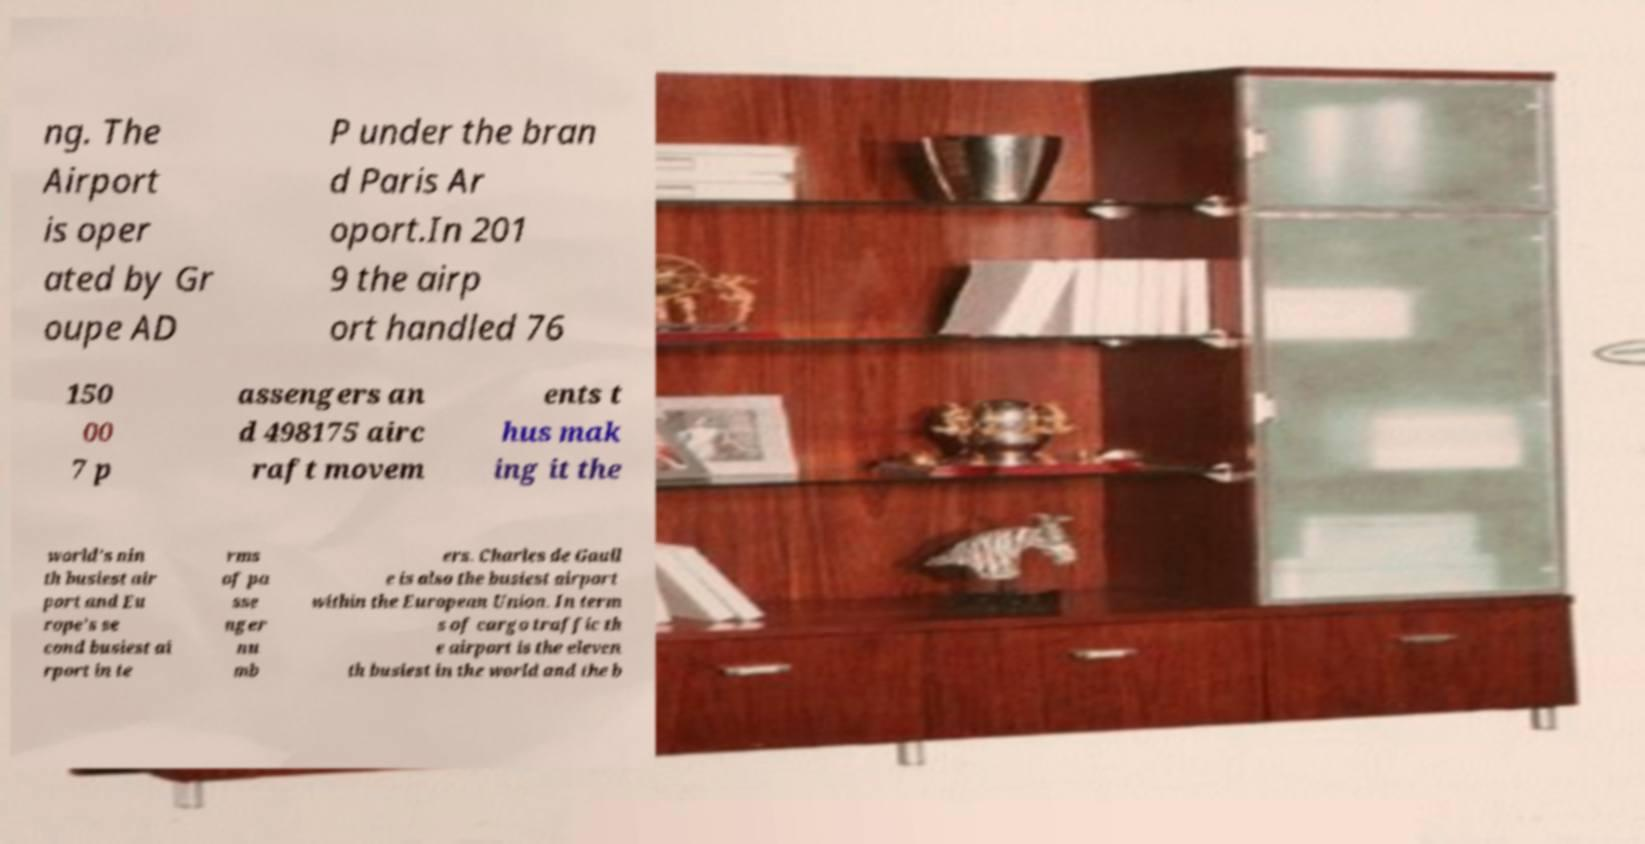I need the written content from this picture converted into text. Can you do that? ng. The Airport is oper ated by Gr oupe AD P under the bran d Paris Ar oport.In 201 9 the airp ort handled 76 150 00 7 p assengers an d 498175 airc raft movem ents t hus mak ing it the world's nin th busiest air port and Eu rope's se cond busiest ai rport in te rms of pa sse nger nu mb ers. Charles de Gaull e is also the busiest airport within the European Union. In term s of cargo traffic th e airport is the eleven th busiest in the world and the b 